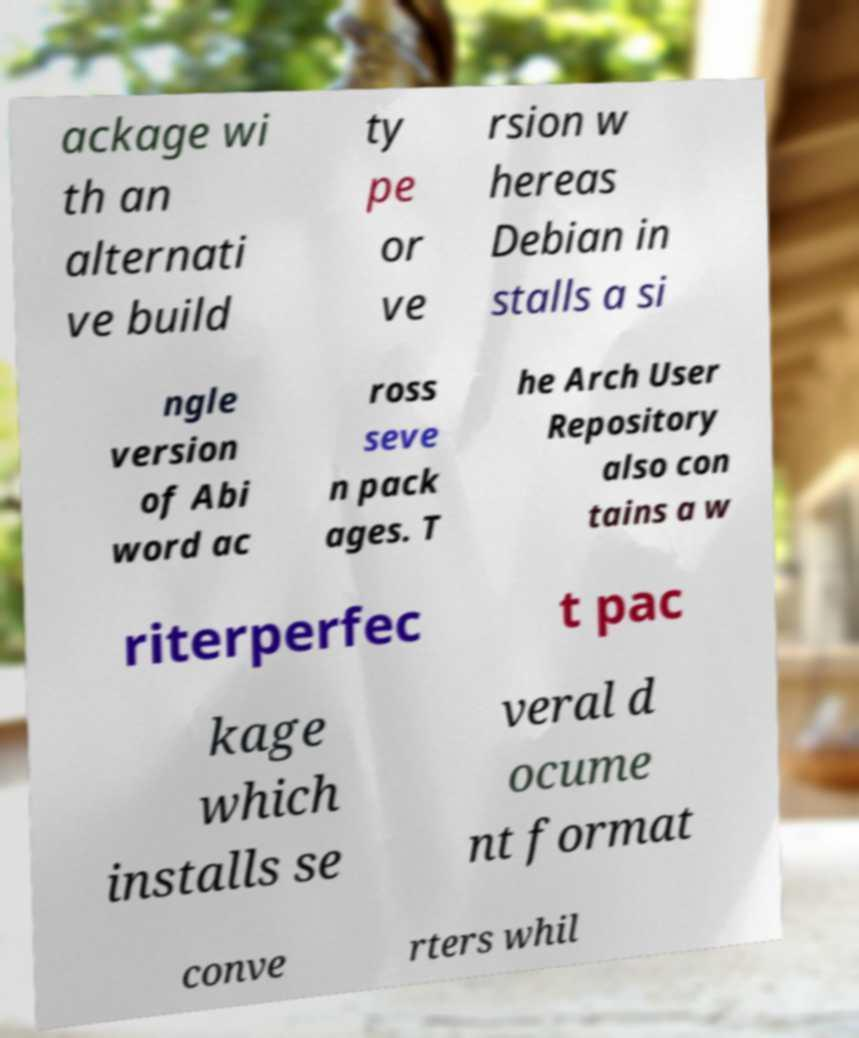Please read and relay the text visible in this image. What does it say? ackage wi th an alternati ve build ty pe or ve rsion w hereas Debian in stalls a si ngle version of Abi word ac ross seve n pack ages. T he Arch User Repository also con tains a w riterperfec t pac kage which installs se veral d ocume nt format conve rters whil 